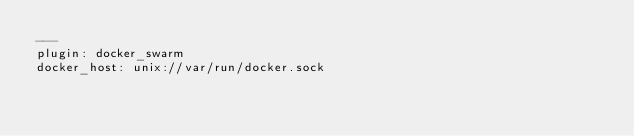<code> <loc_0><loc_0><loc_500><loc_500><_YAML_>---
plugin: docker_swarm
docker_host: unix://var/run/docker.sock
</code> 